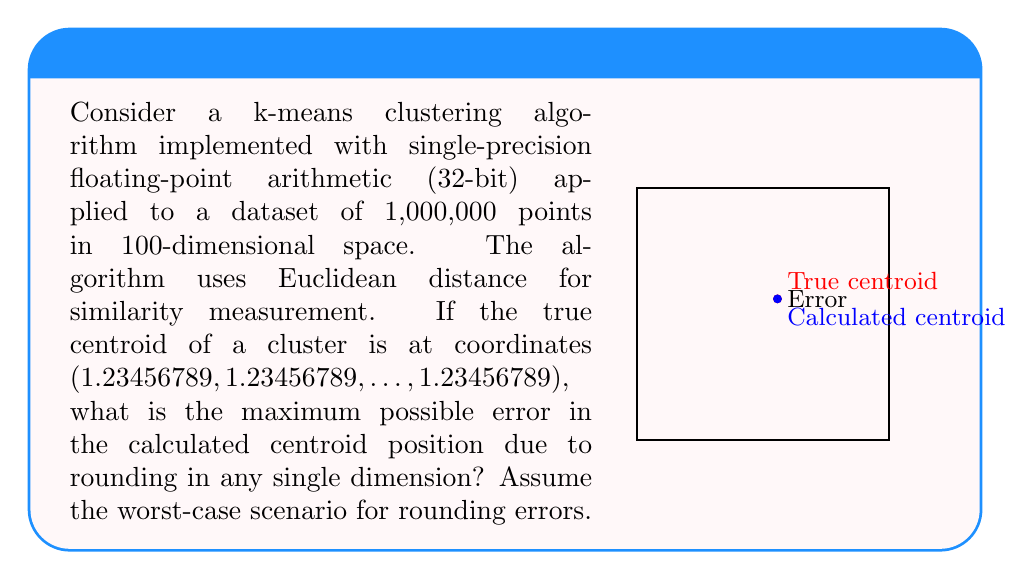Solve this math problem. Let's approach this step-by-step:

1) Single-precision floating-point numbers use 32 bits: 1 for sign, 8 for exponent, and 23 for significand (mantissa).

2) The number 1.23456789 in binary is:
   $1.0011110111110011101101_2 \times 2^0$

3) When represented in single-precision, it becomes:
   $1.00111101111100111011010_2 \times 2^0$

4) Converting back to decimal:
   $1.23456788063049316406250$

5) The maximum rounding error occurs when the true value is exactly halfway between two representable floating-point numbers. In this case, the worst-case scenario would be if the true value was:
   $1.234375_10 = 1.00111101111100111011011_2 \times 2^0$

6) The difference between this worst-case true value and the represented value is:
   $1.234375 - 1.23456788063049316406250 = 0.00000011936950683593750$

Therefore, the maximum possible error in any single dimension due to rounding in single-precision floating-point representation is approximately $1.19 \times 10^{-7}$.
Answer: $1.19 \times 10^{-7}$ 